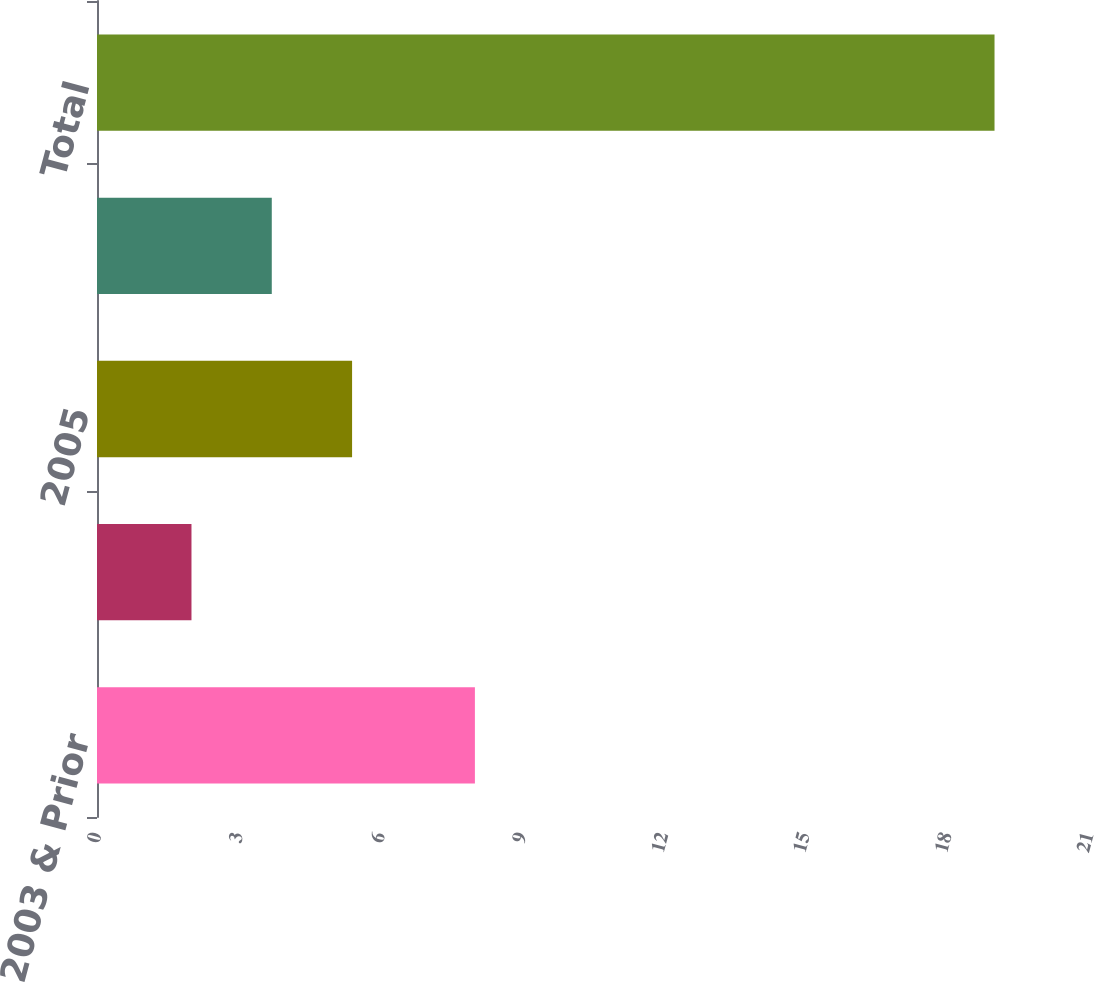Convert chart. <chart><loc_0><loc_0><loc_500><loc_500><bar_chart><fcel>2003 & Prior<fcel>2004<fcel>2005<fcel>2006<fcel>Total<nl><fcel>8<fcel>2<fcel>5.4<fcel>3.7<fcel>19<nl></chart> 